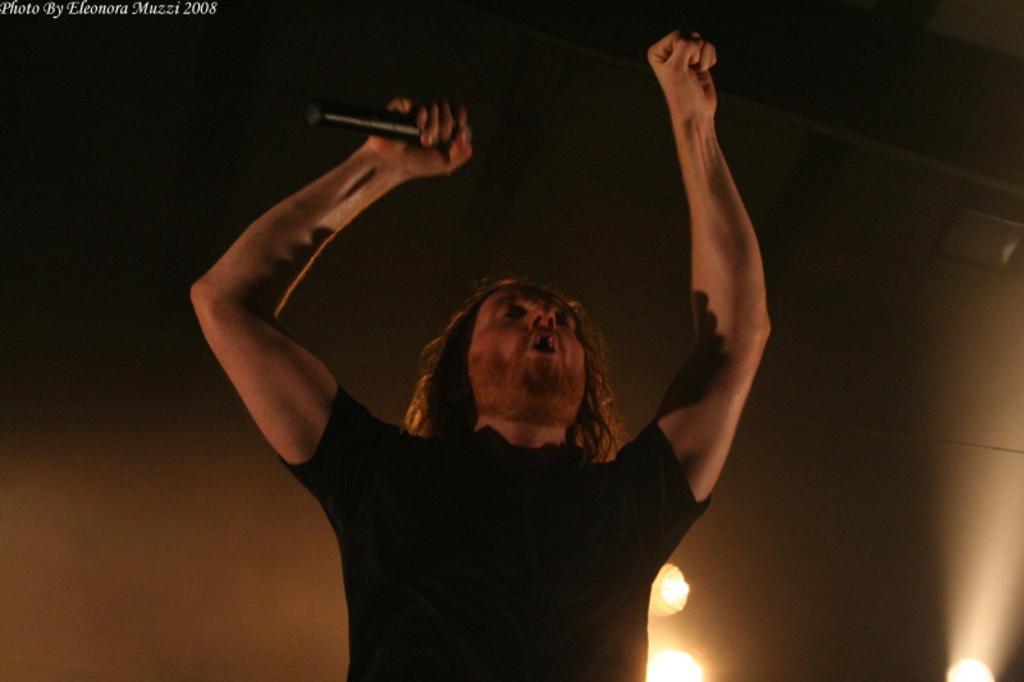Please provide a concise description of this image. In this image there is a man who is wearing the black t-shirt is holding the mic with the hand. He is raising his both the hands. In the background there are lights. 